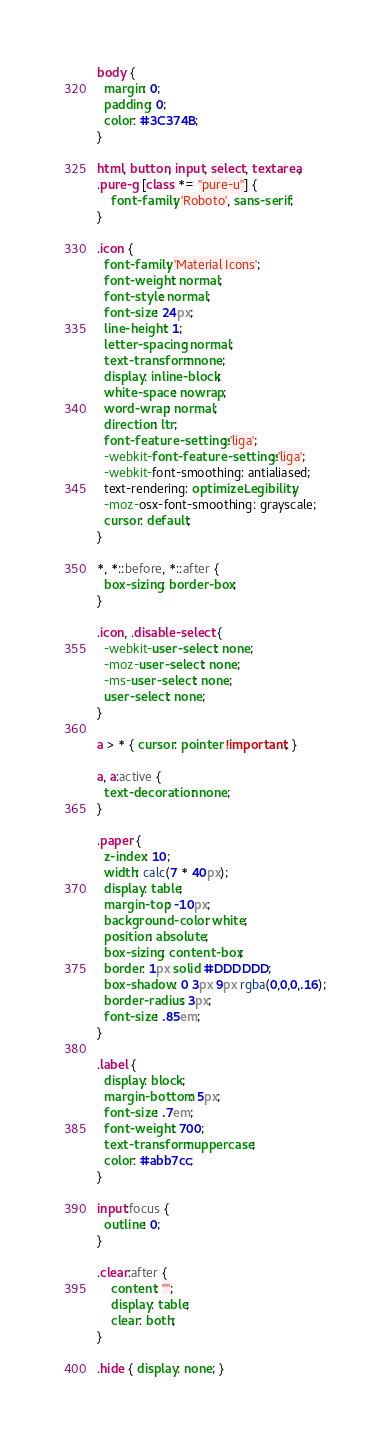Convert code to text. <code><loc_0><loc_0><loc_500><loc_500><_CSS_>body {
  margin: 0;
  padding: 0;
  color: #3C374B;
}

html, button, input, select, textarea,
.pure-g [class *= "pure-u"] {
    font-family: 'Roboto', sans-serif;
}

.icon {
  font-family: 'Material Icons';
  font-weight: normal;
  font-style: normal;
  font-size: 24px;
  line-height: 1;
  letter-spacing: normal;
  text-transform: none;
  display: inline-block;
  white-space: nowrap;
  word-wrap: normal;
  direction: ltr;
  font-feature-settings: 'liga';
  -webkit-font-feature-settings: 'liga';
  -webkit-font-smoothing: antialiased;
  text-rendering: optimizeLegibility;
  -moz-osx-font-smoothing: grayscale;
  cursor: default;
}

*, *::before, *::after {
  box-sizing: border-box;
}

.icon, .disable-select {
  -webkit-user-select: none;
  -moz-user-select: none;
  -ms-user-select: none;
  user-select: none;
}

a > * { cursor: pointer !important; }

a, a:active {
  text-decoration: none;
}

.paper {
  z-index: 10;
  width: calc(7 * 40px);
  display: table;
  margin-top: -10px;
  background-color: white;
  position: absolute;
  box-sizing: content-box;
  border: 1px solid #DDDDDD;
  box-shadow: 0 3px 9px rgba(0,0,0,.16);
  border-radius: 3px;
  font-size: .85em;
}

.label {
  display: block;
  margin-bottom: 5px;
  font-size: .7em;
  font-weight: 700;
  text-transform: uppercase;
  color: #abb7cc;
}

input:focus {
  outline: 0;
}

.clear:after {
    content: "";
    display: table;
    clear: both;
}

.hide { display: none; }</code> 